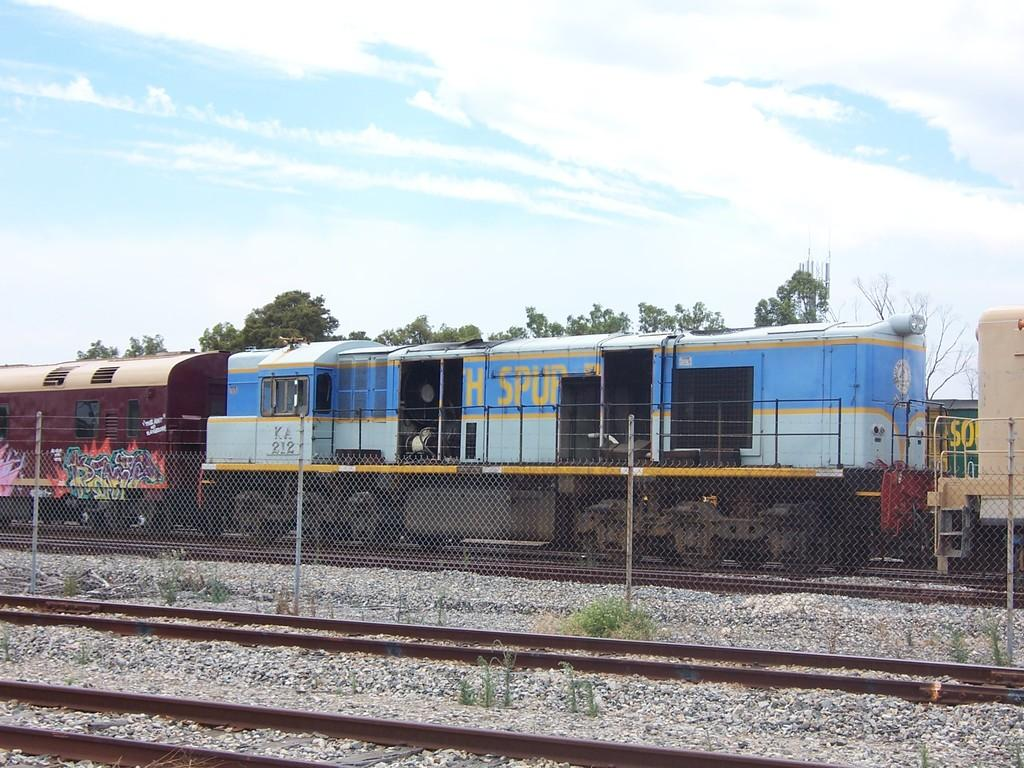What is the main subject of the image? The main subject of the image is a train. Where is the train located in the image? The train is on a railway track. What can be seen in the background of the image? There are trees and the sky visible in the background of the image. What is present at the front of the image? There is fencing at the front of the image. What color is the paint on the cows in the image? There are no cows present in the image, and therefore no paint on cows can be observed. Where is the faucet located in the image? There is no faucet present in the image. 